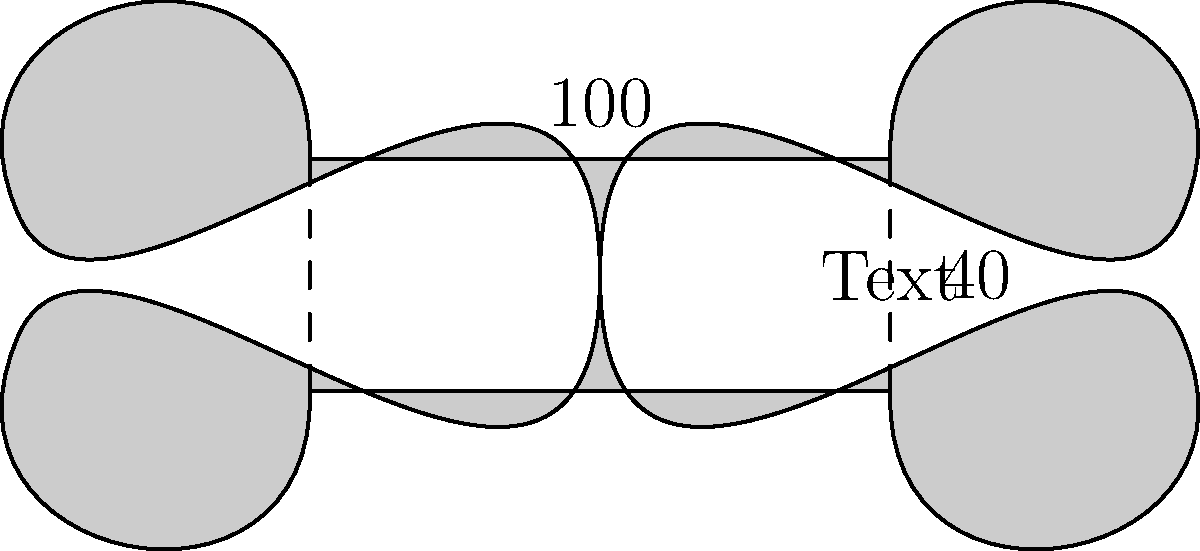As a graphic designer, you're tasked with creating a stylized text banner for a client's website. The banner has curved edges and measures 100 units wide and 40 units tall at its maximum points. Assuming the curved edges can be approximated as straight lines for calculation purposes, what is the approximate perimeter of this banner in units? To calculate the approximate perimeter of the stylized text banner, we'll treat the curved edges as straight lines and use the basic formula for perimeter: sum of all sides.

Step 1: Identify the sides of the banner
- Top and bottom: 100 units each (width)
- Left and right: 40 units each (height)

Step 2: Calculate the perimeter
Perimeter = 2 * (width + height)
           = 2 * (100 + 40)
           = 2 * 140
           = 280 units

Note: This is an approximation as we're treating the curved edges as straight lines. In reality, the curved edges would slightly increase the actual perimeter. However, for practical design purposes, this approximation is often sufficient.

As a graphic designer skeptical of traditional methods, you might appreciate that this quick calculation provides a useful estimate without the need for complex curve measurements or traditional drafting techniques.
Answer: 280 units 